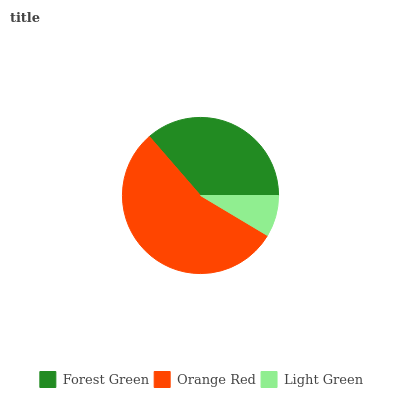Is Light Green the minimum?
Answer yes or no. Yes. Is Orange Red the maximum?
Answer yes or no. Yes. Is Orange Red the minimum?
Answer yes or no. No. Is Light Green the maximum?
Answer yes or no. No. Is Orange Red greater than Light Green?
Answer yes or no. Yes. Is Light Green less than Orange Red?
Answer yes or no. Yes. Is Light Green greater than Orange Red?
Answer yes or no. No. Is Orange Red less than Light Green?
Answer yes or no. No. Is Forest Green the high median?
Answer yes or no. Yes. Is Forest Green the low median?
Answer yes or no. Yes. Is Orange Red the high median?
Answer yes or no. No. Is Light Green the low median?
Answer yes or no. No. 